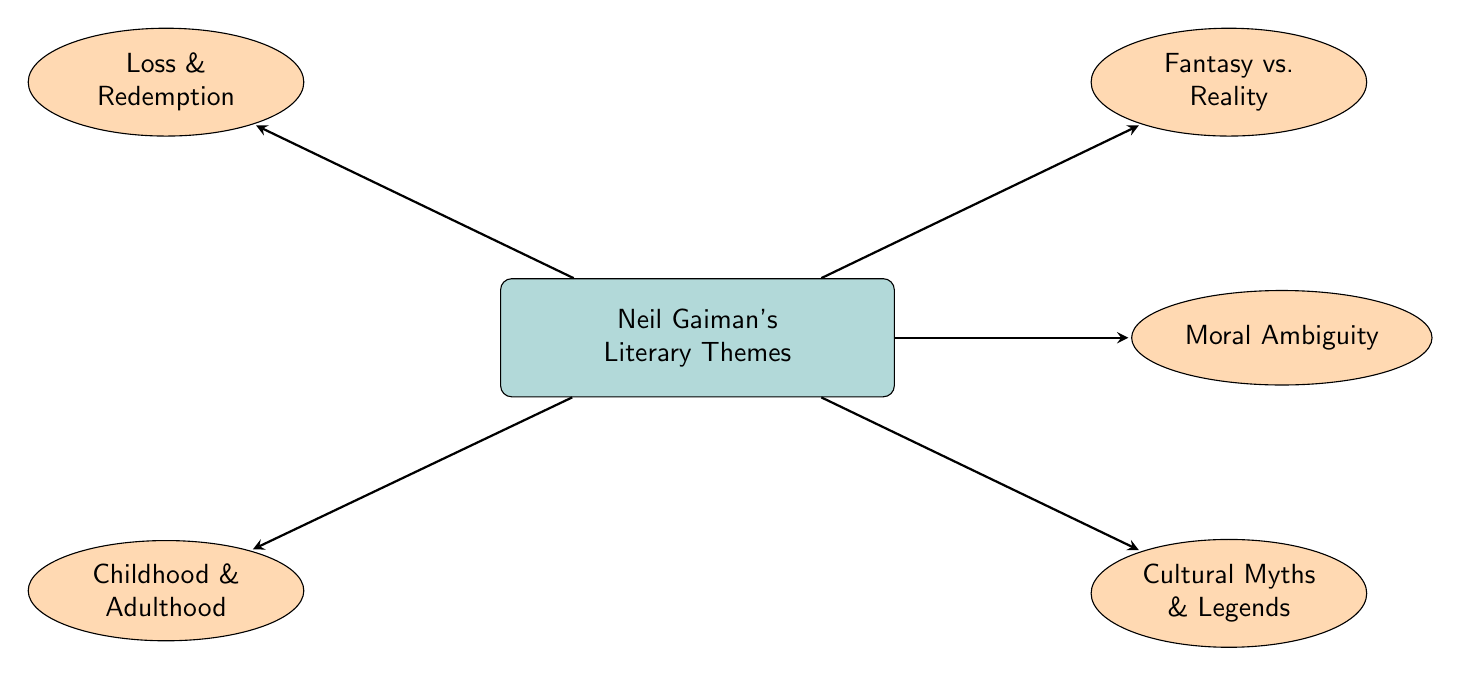What is the main theme of the diagram? The diagram focuses on Neil Gaiman's Literary Themes, as indicated by the central node.
Answer: Neil Gaiman's Literary Themes How many themes are directly related to Neil Gaiman’s Literary Themes? There are five themes represented as nodes emanating from the main theme, connected via edges.
Answer: 5 What theme is associated with the concept of "Loss & Redemption"? The theme "Loss & Redemption" is a direct node connected to the main theme, indicating its association with Neil Gaiman's work.
Answer: Loss & Redemption Is "Moral Ambiguity" a primary theme in the diagram? "Moral Ambiguity" is one of the five themes illustrated as a direct connection emanating from Neil Gaiman’s Literary Themes, which confirms its significance.
Answer: Yes Which theme is positioned above "Childhood & Adulthood"? The theme that is positioned above "Childhood & Adulthood" in the diagram is "Loss & Redemption." The layout clearly shows their positioning in relation to each other.
Answer: Loss & Redemption Are there more themes related to cultural aspects than abstract concepts? The themes "Cultural Myths & Legends," "Loss & Redemption," and "Childhood & Adulthood" can be interpreted as culturally-oriented, while "Moral Ambiguity" and "Fantasy vs. Reality" leans more towards abstract concepts. There are three cultural themes versus two abstract themes.
Answer: Yes Which two themes are directly linked to the notion of reality? "Fantasy vs. Reality" is explicitly linked to the concept of reality, while "Moral Ambiguity" often explores complex real-world ethical dilemmas, indicating a thematic connection.
Answer: Fantasy vs. Reality and Moral Ambiguity 